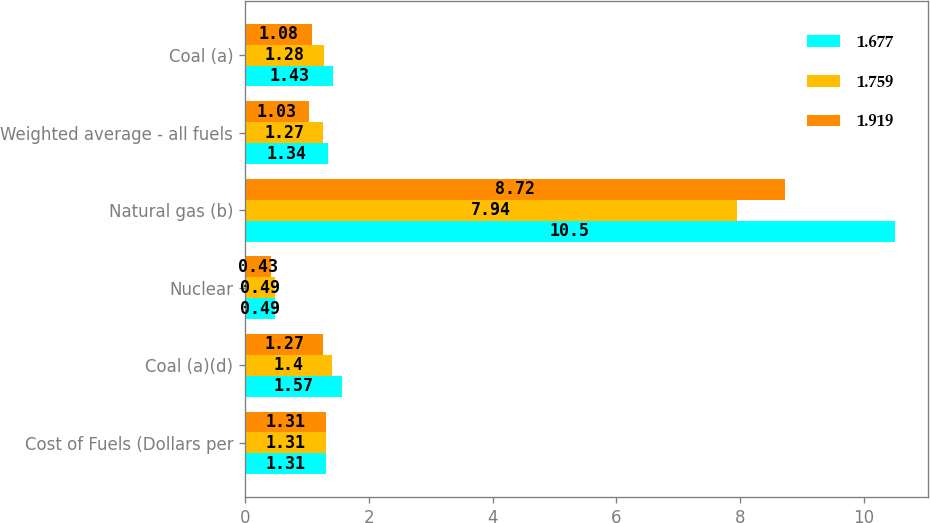<chart> <loc_0><loc_0><loc_500><loc_500><stacked_bar_chart><ecel><fcel>Cost of Fuels (Dollars per<fcel>Coal (a)(d)<fcel>Nuclear<fcel>Natural gas (b)<fcel>Weighted average - all fuels<fcel>Coal (a)<nl><fcel>1.677<fcel>1.31<fcel>1.57<fcel>0.49<fcel>10.5<fcel>1.34<fcel>1.43<nl><fcel>1.759<fcel>1.31<fcel>1.4<fcel>0.49<fcel>7.94<fcel>1.27<fcel>1.28<nl><fcel>1.919<fcel>1.31<fcel>1.27<fcel>0.43<fcel>8.72<fcel>1.03<fcel>1.08<nl></chart> 